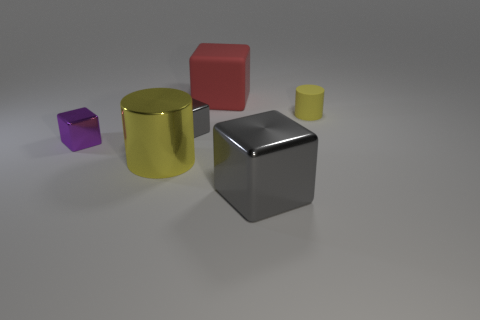Add 2 tiny yellow cylinders. How many objects exist? 8 Subtract all cylinders. How many objects are left? 4 Subtract 0 yellow cubes. How many objects are left? 6 Subtract all tiny cylinders. Subtract all small purple blocks. How many objects are left? 4 Add 6 purple objects. How many purple objects are left? 7 Add 5 large rubber cubes. How many large rubber cubes exist? 6 